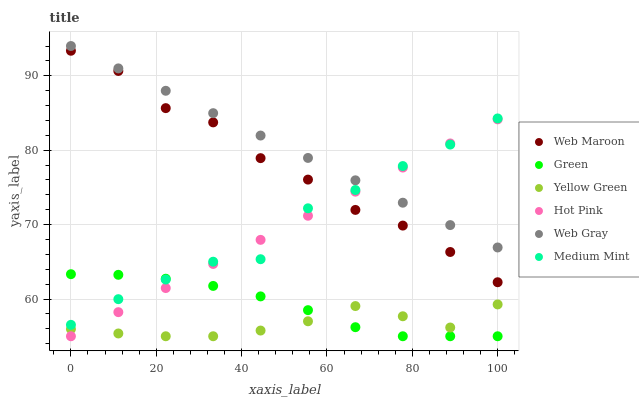Does Yellow Green have the minimum area under the curve?
Answer yes or no. Yes. Does Web Gray have the maximum area under the curve?
Answer yes or no. Yes. Does Web Gray have the minimum area under the curve?
Answer yes or no. No. Does Yellow Green have the maximum area under the curve?
Answer yes or no. No. Is Web Gray the smoothest?
Answer yes or no. Yes. Is Medium Mint the roughest?
Answer yes or no. Yes. Is Yellow Green the smoothest?
Answer yes or no. No. Is Yellow Green the roughest?
Answer yes or no. No. Does Yellow Green have the lowest value?
Answer yes or no. Yes. Does Web Gray have the lowest value?
Answer yes or no. No. Does Web Gray have the highest value?
Answer yes or no. Yes. Does Yellow Green have the highest value?
Answer yes or no. No. Is Yellow Green less than Medium Mint?
Answer yes or no. Yes. Is Web Maroon greater than Yellow Green?
Answer yes or no. Yes. Does Medium Mint intersect Web Gray?
Answer yes or no. Yes. Is Medium Mint less than Web Gray?
Answer yes or no. No. Is Medium Mint greater than Web Gray?
Answer yes or no. No. Does Yellow Green intersect Medium Mint?
Answer yes or no. No. 